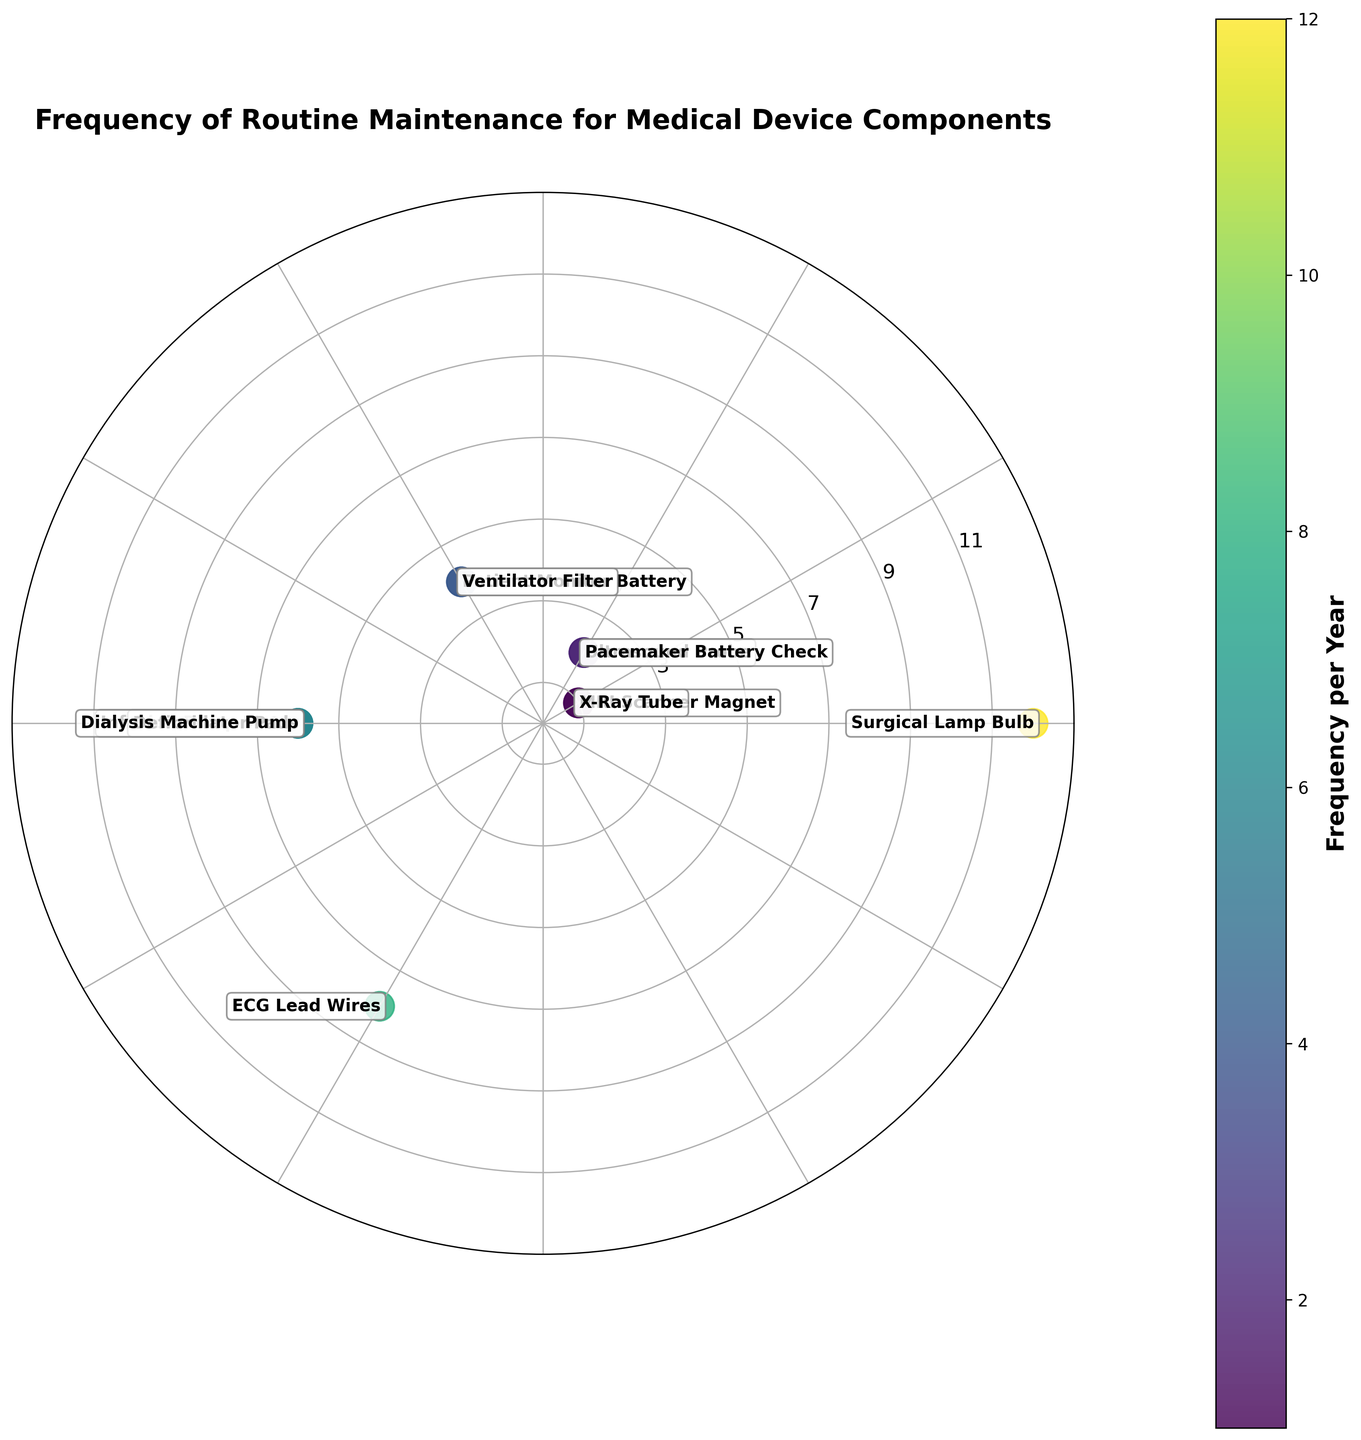What is the title of the plot? The title of the plot is located at the top and is usually large and bold. It reads "Frequency of Routine Maintenance for Medical Device Components".
Answer: Frequency of Routine Maintenance for Medical Device Components How many components require maintenance at least 6 times per year? In the figure, look for data points with frequency values of 6 or more. The components are Surgical Lamp Bulb (12), Infusion Pump Motor (6), Defibrillator Pads (6), ECG Lead Wires (8), and Dialysis Machine Pump (6).
Answer: 5 Which component has the highest frequency of routine maintenance? Identify the data point that is the furthest from the center and check its label. In this case, the Surgical Lamp Bulb has the highest frequency of 12.
Answer: Surgical Lamp Bulb Compare the frequency of maintenance for the MRI Scanner Magnet and the X-Ray Tube. Which one requires more frequent maintenance? Locate both the MRI Scanner Magnet and the X-Ray Tube on the plot and compare their distances from the center. Both have the same frequency at 1, which means neither requires more frequent maintenance than the other.
Answer: Both are equal How often is the Ventilator Filter maintained compared to the Ultrasound Probe? Find the data points for the Ventilator Filter and the Ultrasound Probe. The Ventilator Filter has a frequency of 4, while the Ultrasound Probe has a frequency of 2. So, the Ventilator Filter is maintained twice as often.
Answer: Twice as often What is the average frequency of maintenance for all the components shown? Calculate the average by summing all the frequencies and then dividing by the number of components. The frequencies sum to 54, and there are 11 components. The average frequency is 54/11 = 4.91.
Answer: 4.91 Identify the component with the lowest frequency of routine maintenance and state its frequency. The data points closest to the center represent the lowest frequencies. Both the MRI Scanner Magnet and the X-Ray Tube are closest with a frequency of 1.
Answer: MRI Scanner Magnet and X-Ray Tube, 1 How many components require maintenance exactly 6 times per year? Scan the plot to find all data points on the circle representing 6 times per year. The components are Infusion Pump Motor, Defibrillator Pads, and Dialysis Machine Pump.
Answer: 3 What is the summed frequency of maintenance for the Pacemaker Battery Check and the Ultrasound Probe? Add the frequencies of the Pacemaker Battery Check (2) and the Ultrasound Probe (2). 2 + 2 = 4.
Answer: 4 Which component requires more frequent maintenance: the Ventilator Filter or the Patient Monitor Battery? Look for the data points for both components and compare their distances from the center. The Ventilator Filter is maintained 4 times per year, while the Patient Monitor Battery is also maintained 4 times per year. Hence, they are equal.
Answer: Both are equal 